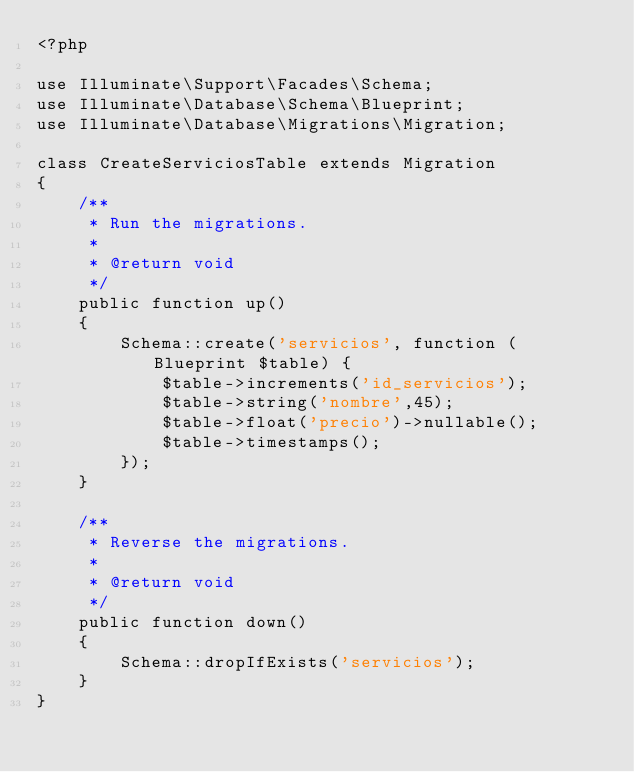Convert code to text. <code><loc_0><loc_0><loc_500><loc_500><_PHP_><?php

use Illuminate\Support\Facades\Schema;
use Illuminate\Database\Schema\Blueprint;
use Illuminate\Database\Migrations\Migration;

class CreateServiciosTable extends Migration
{
    /**
     * Run the migrations.
     *
     * @return void
     */
    public function up()
    {
        Schema::create('servicios', function (Blueprint $table) {
            $table->increments('id_servicios');
            $table->string('nombre',45);
            $table->float('precio')->nullable();
            $table->timestamps();
        });
    }

    /**
     * Reverse the migrations.
     *
     * @return void
     */
    public function down()
    {
        Schema::dropIfExists('servicios');
    }
}
</code> 